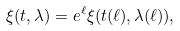<formula> <loc_0><loc_0><loc_500><loc_500>\xi ( t , \lambda ) = e ^ { \ell } \xi ( t ( \ell ) , \lambda ( \ell ) ) ,</formula> 